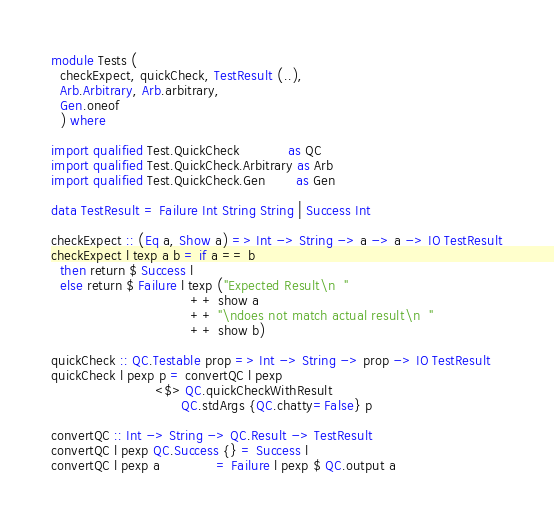<code> <loc_0><loc_0><loc_500><loc_500><_Haskell_>module Tests (
  checkExpect, quickCheck, TestResult (..),
  Arb.Arbitrary, Arb.arbitrary,
  Gen.oneof
  ) where

import qualified Test.QuickCheck           as QC
import qualified Test.QuickCheck.Arbitrary as Arb
import qualified Test.QuickCheck.Gen       as Gen

data TestResult = Failure Int String String | Success Int

checkExpect :: (Eq a, Show a) => Int -> String -> a -> a -> IO TestResult
checkExpect l texp a b = if a == b
  then return $ Success l
  else return $ Failure l texp ("Expected Result\n  "
                                ++ show a
                                ++ "\ndoes not match actual result\n  "
                                ++ show b)

quickCheck :: QC.Testable prop => Int -> String -> prop -> IO TestResult
quickCheck l pexp p = convertQC l pexp
                        <$> QC.quickCheckWithResult
                              QC.stdArgs {QC.chatty=False} p

convertQC :: Int -> String -> QC.Result -> TestResult
convertQC l pexp QC.Success {} = Success l
convertQC l pexp a             = Failure l pexp $ QC.output a
</code> 